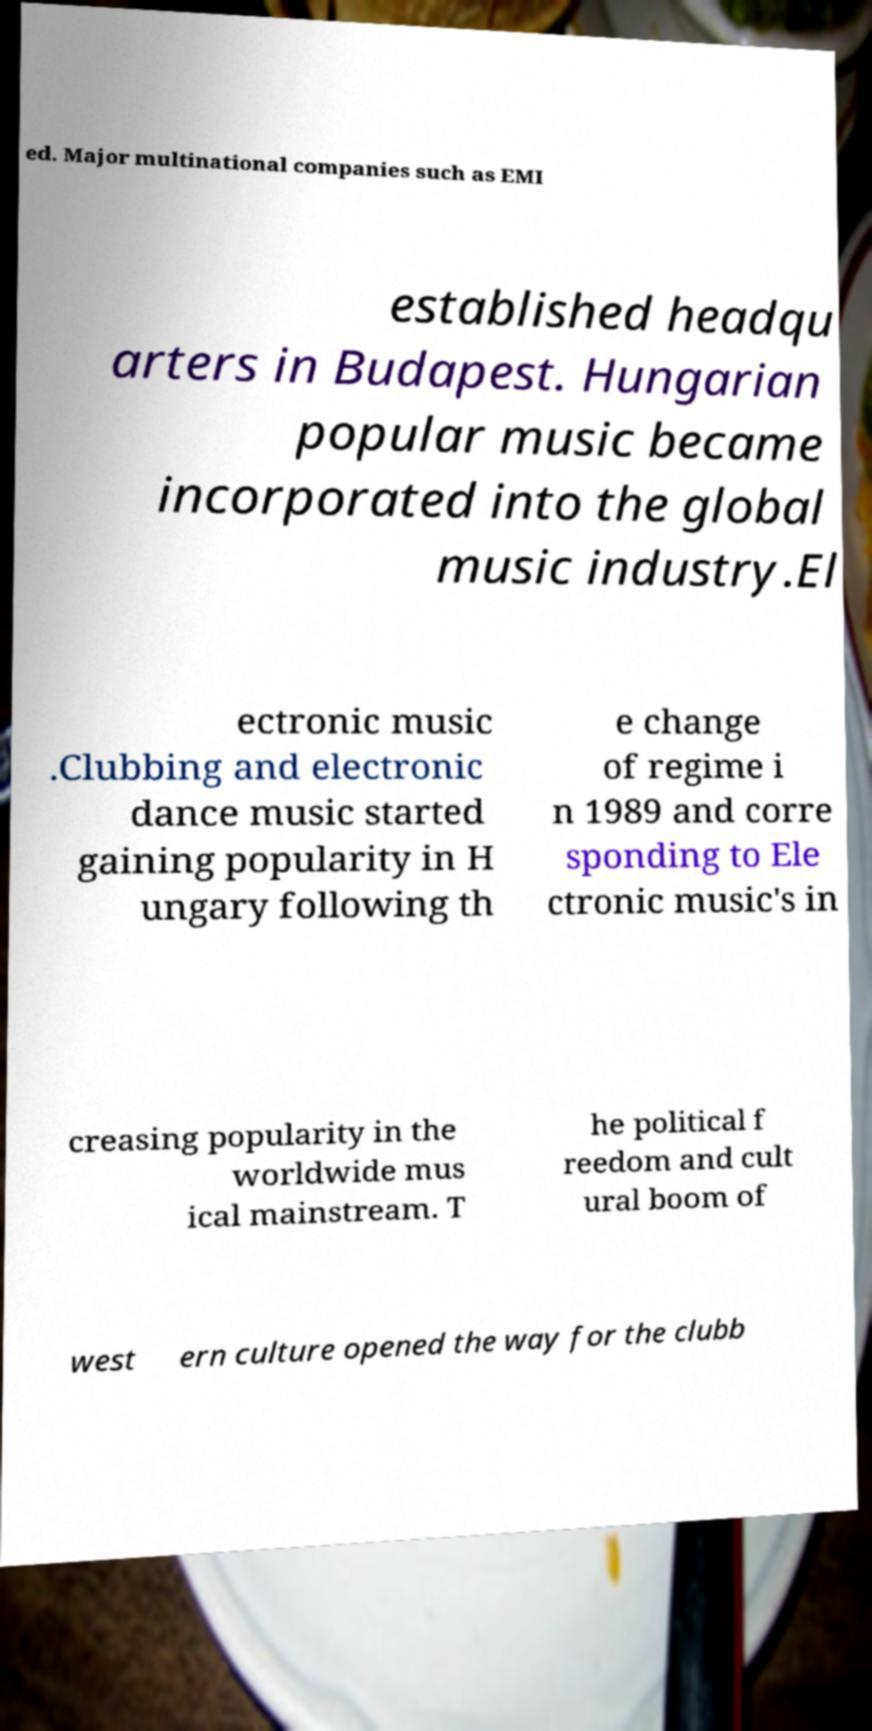Could you extract and type out the text from this image? ed. Major multinational companies such as EMI established headqu arters in Budapest. Hungarian popular music became incorporated into the global music industry.El ectronic music .Clubbing and electronic dance music started gaining popularity in H ungary following th e change of regime i n 1989 and corre sponding to Ele ctronic music's in creasing popularity in the worldwide mus ical mainstream. T he political f reedom and cult ural boom of west ern culture opened the way for the clubb 